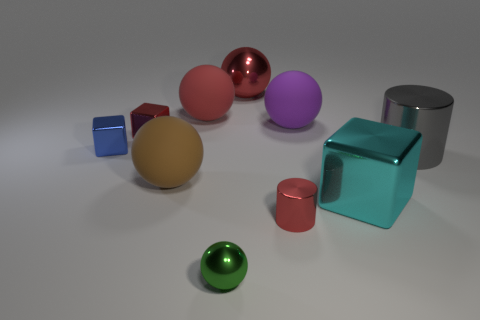Subtract all brown rubber balls. How many balls are left? 4 Subtract all purple balls. How many balls are left? 4 Subtract all cyan balls. Subtract all brown cubes. How many balls are left? 5 Subtract all cylinders. How many objects are left? 8 Add 5 large metallic spheres. How many large metallic spheres are left? 6 Add 6 large red cubes. How many large red cubes exist? 6 Subtract 1 cyan cubes. How many objects are left? 9 Subtract all red matte blocks. Subtract all brown matte things. How many objects are left? 9 